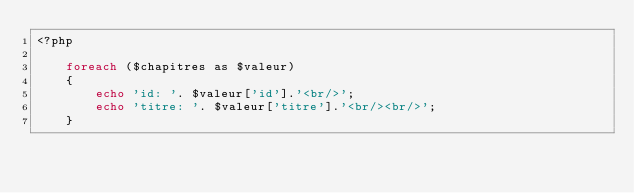Convert code to text. <code><loc_0><loc_0><loc_500><loc_500><_PHP_><?php

    foreach ($chapitres as $valeur)
    {
        echo 'id: '. $valeur['id'].'<br/>';
        echo 'titre: '. $valeur['titre'].'<br/><br/>';
    }</code> 